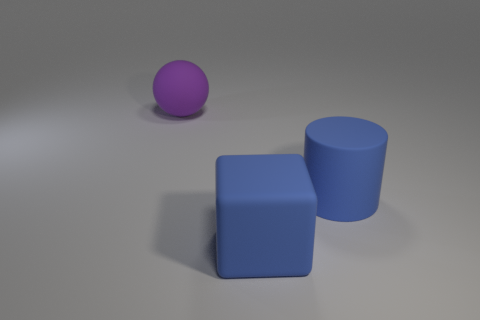Are there more blue rubber cylinders to the right of the blue cylinder than big purple balls that are in front of the purple rubber ball?
Offer a very short reply. No. What number of objects are blue rubber cylinders or large blue matte objects?
Keep it short and to the point. 2. How many other objects are the same color as the rubber cylinder?
Your answer should be compact. 1. What shape is the blue thing that is the same size as the cube?
Your answer should be very brief. Cylinder. The object behind the big cylinder is what color?
Provide a succinct answer. Purple. What number of objects are either rubber objects that are right of the big ball or big rubber objects that are to the right of the ball?
Offer a terse response. 2. Is the matte block the same size as the blue matte cylinder?
Your answer should be compact. Yes. What number of balls are either gray matte things or blue things?
Keep it short and to the point. 0. What number of big rubber things are to the left of the large block and on the right side of the large purple rubber thing?
Your response must be concise. 0. Does the blue cylinder have the same size as the rubber thing that is left of the rubber cube?
Ensure brevity in your answer.  Yes. 